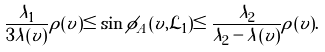<formula> <loc_0><loc_0><loc_500><loc_500>\frac { \lambda _ { 1 } } { 3 \lambda ( v ) } \rho ( v ) \leq \sin \phi _ { A } ( v , \mathcal { L } _ { 1 } ) \leq \frac { \lambda _ { 2 } } { \lambda _ { 2 } - \lambda ( v ) } \rho ( v ) .</formula> 